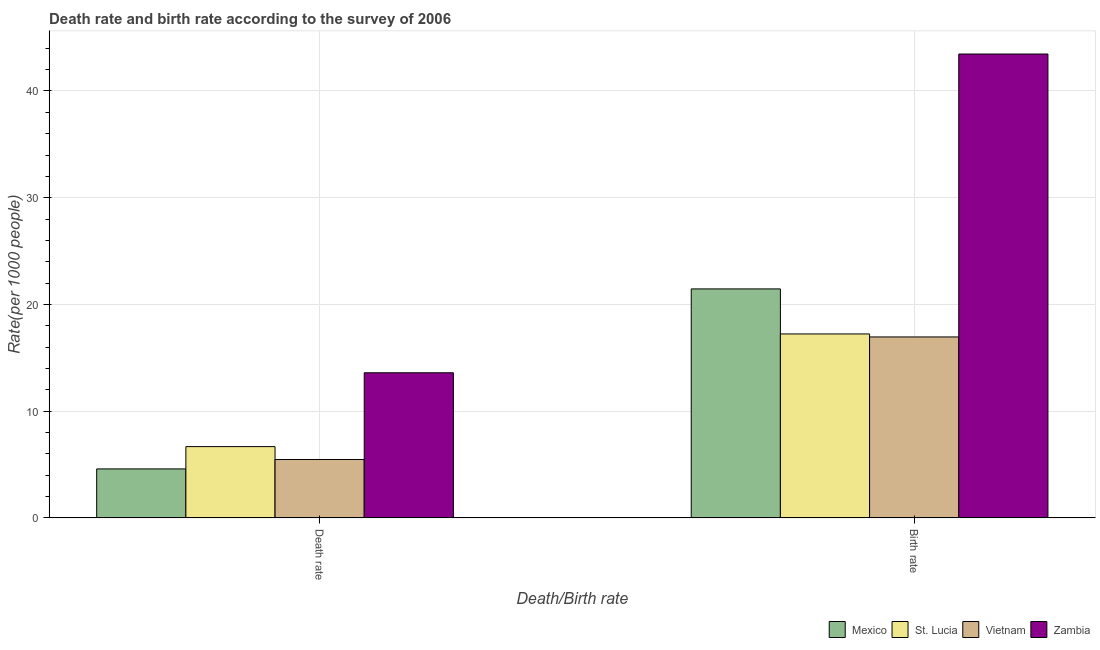Are the number of bars per tick equal to the number of legend labels?
Provide a short and direct response. Yes. Are the number of bars on each tick of the X-axis equal?
Keep it short and to the point. Yes. How many bars are there on the 2nd tick from the left?
Give a very brief answer. 4. What is the label of the 1st group of bars from the left?
Offer a terse response. Death rate. What is the birth rate in Zambia?
Provide a succinct answer. 43.46. Across all countries, what is the maximum birth rate?
Keep it short and to the point. 43.46. Across all countries, what is the minimum death rate?
Ensure brevity in your answer.  4.59. In which country was the birth rate maximum?
Give a very brief answer. Zambia. In which country was the death rate minimum?
Ensure brevity in your answer.  Mexico. What is the total birth rate in the graph?
Ensure brevity in your answer.  99.11. What is the difference between the birth rate in St. Lucia and that in Mexico?
Your response must be concise. -4.22. What is the difference between the birth rate in Zambia and the death rate in St. Lucia?
Offer a very short reply. 36.78. What is the average death rate per country?
Offer a terse response. 7.59. What is the difference between the death rate and birth rate in St. Lucia?
Your answer should be very brief. -10.56. What is the ratio of the birth rate in Mexico to that in Zambia?
Your response must be concise. 0.49. Is the birth rate in Vietnam less than that in St. Lucia?
Offer a very short reply. Yes. What does the 4th bar from the left in Birth rate represents?
Make the answer very short. Zambia. What does the 2nd bar from the right in Death rate represents?
Your answer should be compact. Vietnam. How many bars are there?
Your answer should be very brief. 8. Are all the bars in the graph horizontal?
Offer a terse response. No. What is the difference between two consecutive major ticks on the Y-axis?
Your answer should be compact. 10. Are the values on the major ticks of Y-axis written in scientific E-notation?
Offer a terse response. No. Does the graph contain any zero values?
Your response must be concise. No. What is the title of the graph?
Offer a very short reply. Death rate and birth rate according to the survey of 2006. What is the label or title of the X-axis?
Provide a short and direct response. Death/Birth rate. What is the label or title of the Y-axis?
Give a very brief answer. Rate(per 1000 people). What is the Rate(per 1000 people) of Mexico in Death rate?
Keep it short and to the point. 4.59. What is the Rate(per 1000 people) in St. Lucia in Death rate?
Make the answer very short. 6.68. What is the Rate(per 1000 people) of Vietnam in Death rate?
Offer a terse response. 5.47. What is the Rate(per 1000 people) in Zambia in Death rate?
Your response must be concise. 13.6. What is the Rate(per 1000 people) of Mexico in Birth rate?
Offer a very short reply. 21.45. What is the Rate(per 1000 people) in St. Lucia in Birth rate?
Your answer should be very brief. 17.24. What is the Rate(per 1000 people) in Vietnam in Birth rate?
Offer a very short reply. 16.95. What is the Rate(per 1000 people) in Zambia in Birth rate?
Make the answer very short. 43.46. Across all Death/Birth rate, what is the maximum Rate(per 1000 people) of Mexico?
Offer a very short reply. 21.45. Across all Death/Birth rate, what is the maximum Rate(per 1000 people) of St. Lucia?
Keep it short and to the point. 17.24. Across all Death/Birth rate, what is the maximum Rate(per 1000 people) of Vietnam?
Provide a short and direct response. 16.95. Across all Death/Birth rate, what is the maximum Rate(per 1000 people) in Zambia?
Offer a terse response. 43.46. Across all Death/Birth rate, what is the minimum Rate(per 1000 people) in Mexico?
Your answer should be compact. 4.59. Across all Death/Birth rate, what is the minimum Rate(per 1000 people) of St. Lucia?
Your answer should be very brief. 6.68. Across all Death/Birth rate, what is the minimum Rate(per 1000 people) of Vietnam?
Make the answer very short. 5.47. Across all Death/Birth rate, what is the minimum Rate(per 1000 people) of Zambia?
Make the answer very short. 13.6. What is the total Rate(per 1000 people) of Mexico in the graph?
Make the answer very short. 26.04. What is the total Rate(per 1000 people) of St. Lucia in the graph?
Your answer should be very brief. 23.92. What is the total Rate(per 1000 people) of Vietnam in the graph?
Your answer should be very brief. 22.43. What is the total Rate(per 1000 people) of Zambia in the graph?
Provide a succinct answer. 57.06. What is the difference between the Rate(per 1000 people) in Mexico in Death rate and that in Birth rate?
Offer a very short reply. -16.86. What is the difference between the Rate(per 1000 people) in St. Lucia in Death rate and that in Birth rate?
Offer a terse response. -10.56. What is the difference between the Rate(per 1000 people) in Vietnam in Death rate and that in Birth rate?
Offer a terse response. -11.48. What is the difference between the Rate(per 1000 people) of Zambia in Death rate and that in Birth rate?
Offer a very short reply. -29.86. What is the difference between the Rate(per 1000 people) in Mexico in Death rate and the Rate(per 1000 people) in St. Lucia in Birth rate?
Make the answer very short. -12.65. What is the difference between the Rate(per 1000 people) of Mexico in Death rate and the Rate(per 1000 people) of Vietnam in Birth rate?
Your answer should be very brief. -12.37. What is the difference between the Rate(per 1000 people) of Mexico in Death rate and the Rate(per 1000 people) of Zambia in Birth rate?
Offer a terse response. -38.87. What is the difference between the Rate(per 1000 people) in St. Lucia in Death rate and the Rate(per 1000 people) in Vietnam in Birth rate?
Provide a succinct answer. -10.28. What is the difference between the Rate(per 1000 people) in St. Lucia in Death rate and the Rate(per 1000 people) in Zambia in Birth rate?
Your answer should be very brief. -36.78. What is the difference between the Rate(per 1000 people) of Vietnam in Death rate and the Rate(per 1000 people) of Zambia in Birth rate?
Provide a succinct answer. -37.99. What is the average Rate(per 1000 people) in Mexico per Death/Birth rate?
Your answer should be very brief. 13.02. What is the average Rate(per 1000 people) of St. Lucia per Death/Birth rate?
Your answer should be very brief. 11.96. What is the average Rate(per 1000 people) in Vietnam per Death/Birth rate?
Provide a short and direct response. 11.21. What is the average Rate(per 1000 people) in Zambia per Death/Birth rate?
Make the answer very short. 28.53. What is the difference between the Rate(per 1000 people) of Mexico and Rate(per 1000 people) of St. Lucia in Death rate?
Your answer should be very brief. -2.09. What is the difference between the Rate(per 1000 people) in Mexico and Rate(per 1000 people) in Vietnam in Death rate?
Your response must be concise. -0.88. What is the difference between the Rate(per 1000 people) of Mexico and Rate(per 1000 people) of Zambia in Death rate?
Your response must be concise. -9.01. What is the difference between the Rate(per 1000 people) of St. Lucia and Rate(per 1000 people) of Vietnam in Death rate?
Provide a succinct answer. 1.21. What is the difference between the Rate(per 1000 people) of St. Lucia and Rate(per 1000 people) of Zambia in Death rate?
Your answer should be very brief. -6.92. What is the difference between the Rate(per 1000 people) of Vietnam and Rate(per 1000 people) of Zambia in Death rate?
Your answer should be very brief. -8.12. What is the difference between the Rate(per 1000 people) of Mexico and Rate(per 1000 people) of St. Lucia in Birth rate?
Offer a terse response. 4.22. What is the difference between the Rate(per 1000 people) in Mexico and Rate(per 1000 people) in Vietnam in Birth rate?
Give a very brief answer. 4.5. What is the difference between the Rate(per 1000 people) in Mexico and Rate(per 1000 people) in Zambia in Birth rate?
Provide a short and direct response. -22.01. What is the difference between the Rate(per 1000 people) of St. Lucia and Rate(per 1000 people) of Vietnam in Birth rate?
Make the answer very short. 0.28. What is the difference between the Rate(per 1000 people) in St. Lucia and Rate(per 1000 people) in Zambia in Birth rate?
Your answer should be very brief. -26.23. What is the difference between the Rate(per 1000 people) of Vietnam and Rate(per 1000 people) of Zambia in Birth rate?
Provide a succinct answer. -26.51. What is the ratio of the Rate(per 1000 people) in Mexico in Death rate to that in Birth rate?
Give a very brief answer. 0.21. What is the ratio of the Rate(per 1000 people) in St. Lucia in Death rate to that in Birth rate?
Offer a terse response. 0.39. What is the ratio of the Rate(per 1000 people) in Vietnam in Death rate to that in Birth rate?
Keep it short and to the point. 0.32. What is the ratio of the Rate(per 1000 people) in Zambia in Death rate to that in Birth rate?
Keep it short and to the point. 0.31. What is the difference between the highest and the second highest Rate(per 1000 people) in Mexico?
Ensure brevity in your answer.  16.86. What is the difference between the highest and the second highest Rate(per 1000 people) in St. Lucia?
Ensure brevity in your answer.  10.56. What is the difference between the highest and the second highest Rate(per 1000 people) of Vietnam?
Keep it short and to the point. 11.48. What is the difference between the highest and the second highest Rate(per 1000 people) of Zambia?
Provide a succinct answer. 29.86. What is the difference between the highest and the lowest Rate(per 1000 people) of Mexico?
Keep it short and to the point. 16.86. What is the difference between the highest and the lowest Rate(per 1000 people) of St. Lucia?
Give a very brief answer. 10.56. What is the difference between the highest and the lowest Rate(per 1000 people) of Vietnam?
Provide a short and direct response. 11.48. What is the difference between the highest and the lowest Rate(per 1000 people) of Zambia?
Your answer should be very brief. 29.86. 